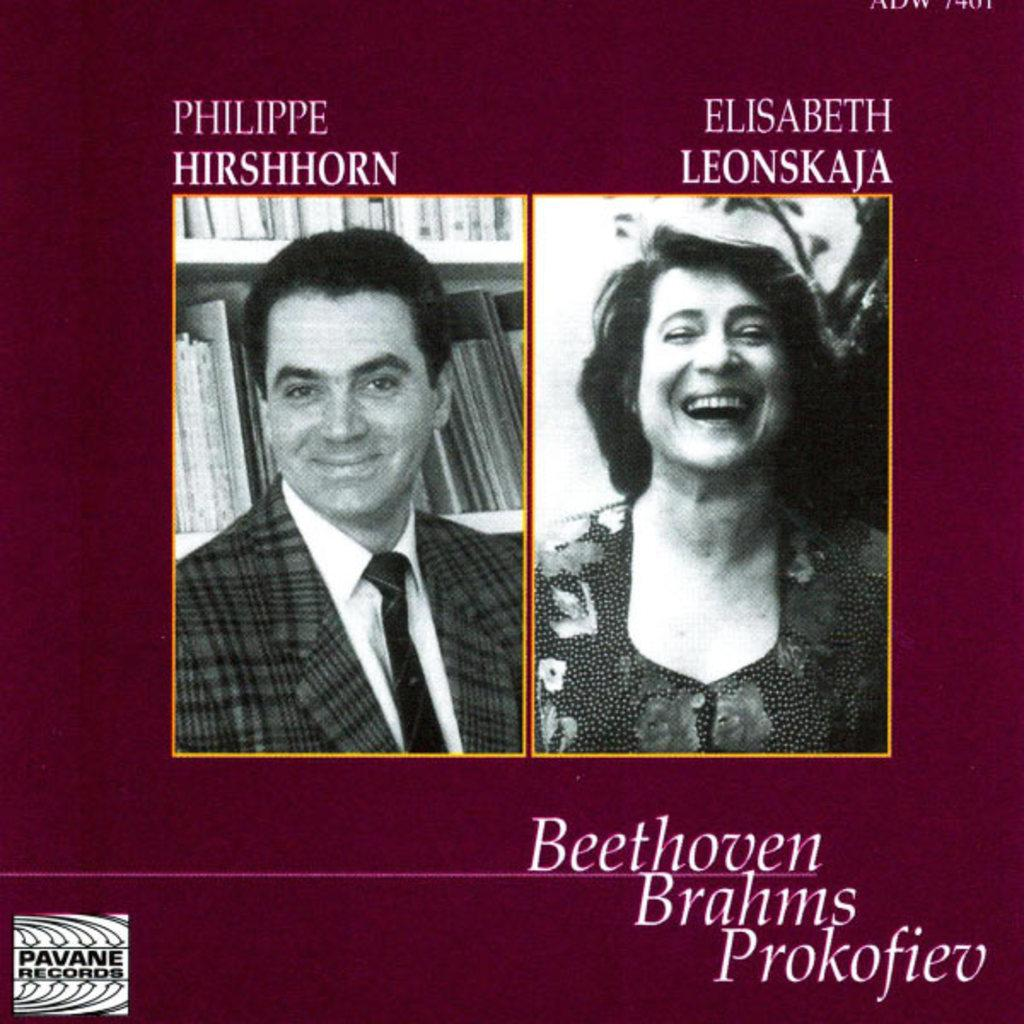What is the composition of the image? The image is a collage of two images. What additional elements are present in the image besides the collage? There is text written above the collage and text written below the collage. What color is the blood dripping from the channel in the image? There is no blood or channel present in the image; it is a collage of two images with text above and below. 